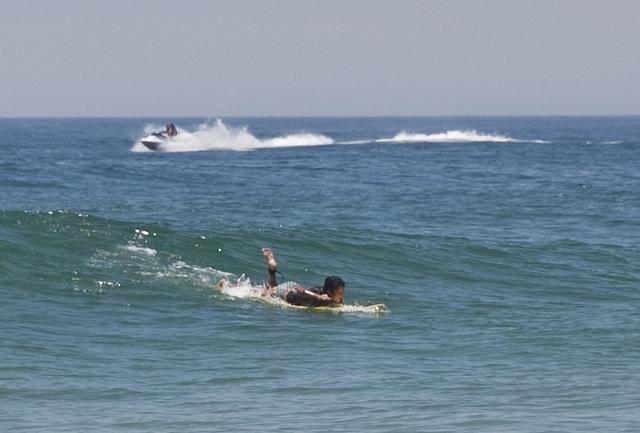Which person seen here goes faster over time?
Make your selection and explain in format: 'Answer: answer
Rationale: rationale.'
Options: Shark rider, boat, surfer, canoe. Answer: boat.
Rationale: The boat can go way faster since it's powered by a motor. 